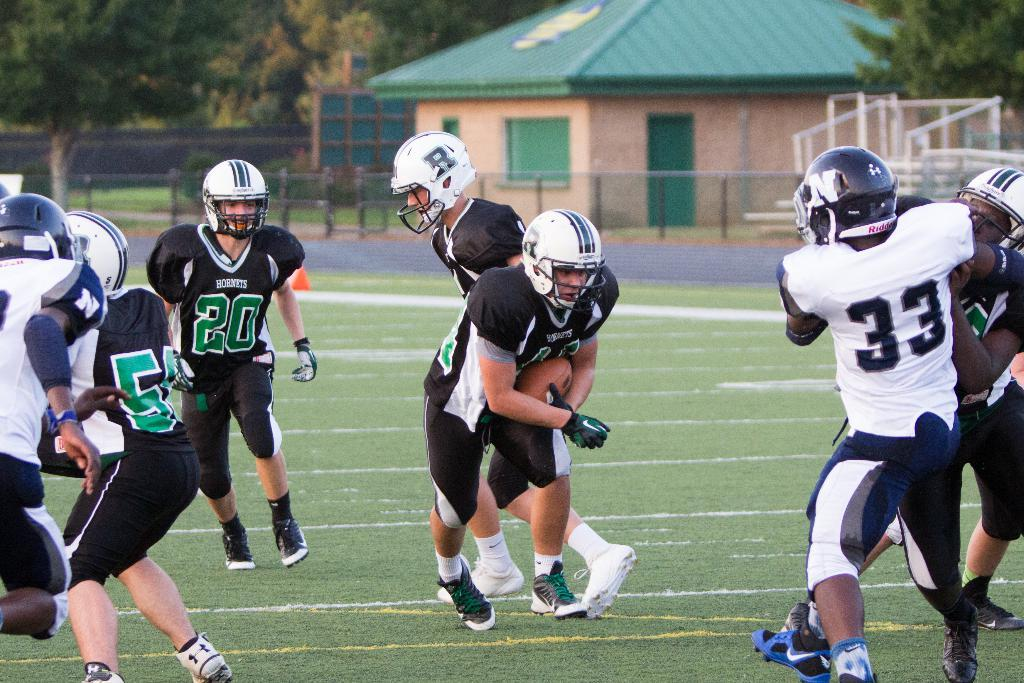What are the people in the image doing? There is a group of people running in the image. What protective gear are the people wearing? The people are wearing helmets. What type of clothing are the people wearing? The people are wearing T-shirts, shorts, and shoes. Where is the image taking place? The image is set in a room with a window and a door. What can be seen outside the room? Trees and a fence are visible in the image. What type of store can be seen in the image? There is no store present in the image; it features a group of people running in a room with a window and a door. What route are the people following in the image? The image does not show a specific route; it only shows the people running in a room. 